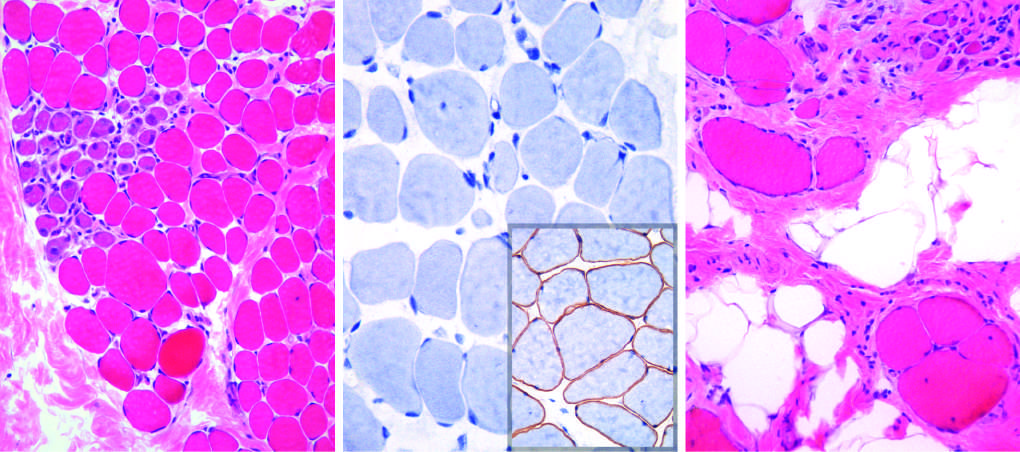what illustrates disease progression, which is marked by extensive variation in myofiber size, fatty replacement, and endomysial fibrosis in (c)?
Answer the question using a single word or phrase. The biopsy from the older brother 